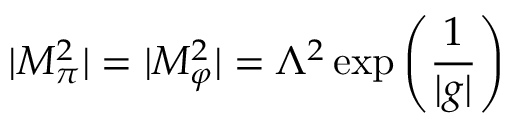Convert formula to latex. <formula><loc_0><loc_0><loc_500><loc_500>| M _ { \pi } ^ { 2 } | = | M _ { \varphi } ^ { 2 } | = \Lambda ^ { 2 } \exp \left ( \frac { 1 } { | g | } \right )</formula> 